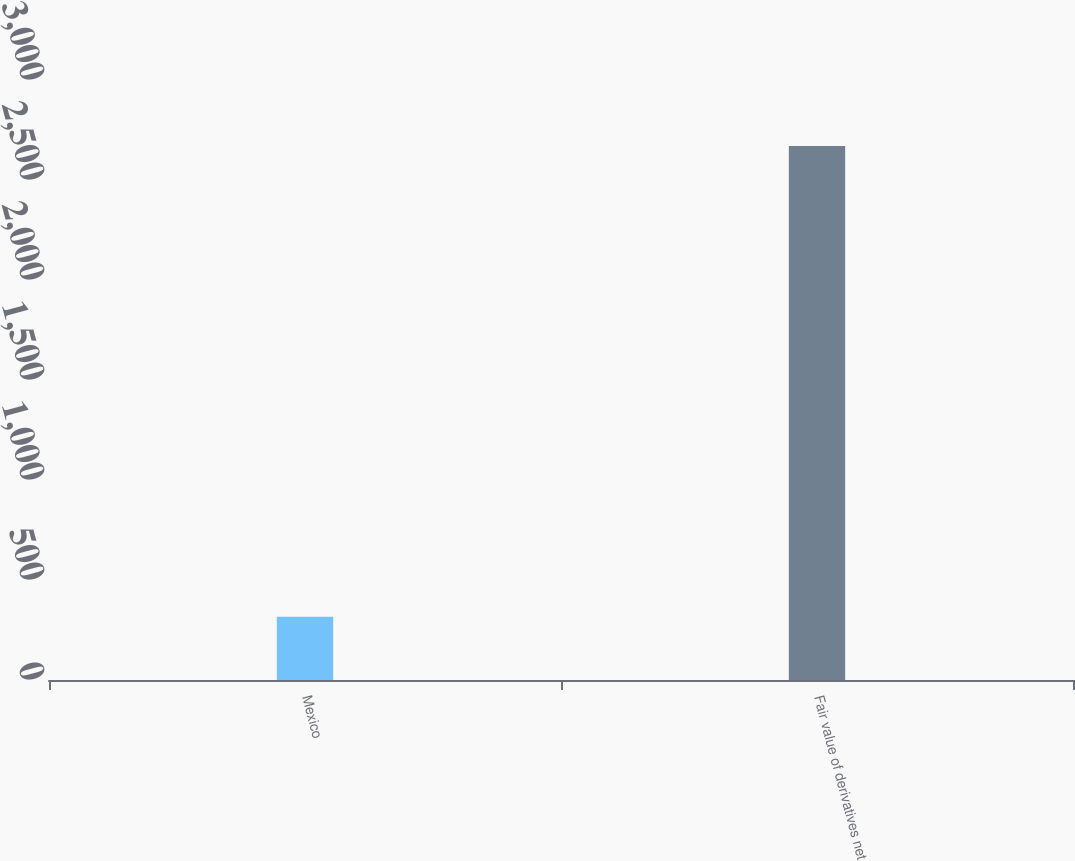<chart> <loc_0><loc_0><loc_500><loc_500><bar_chart><fcel>Mexico<fcel>Fair value of derivatives net<nl><fcel>316<fcel>2670<nl></chart> 